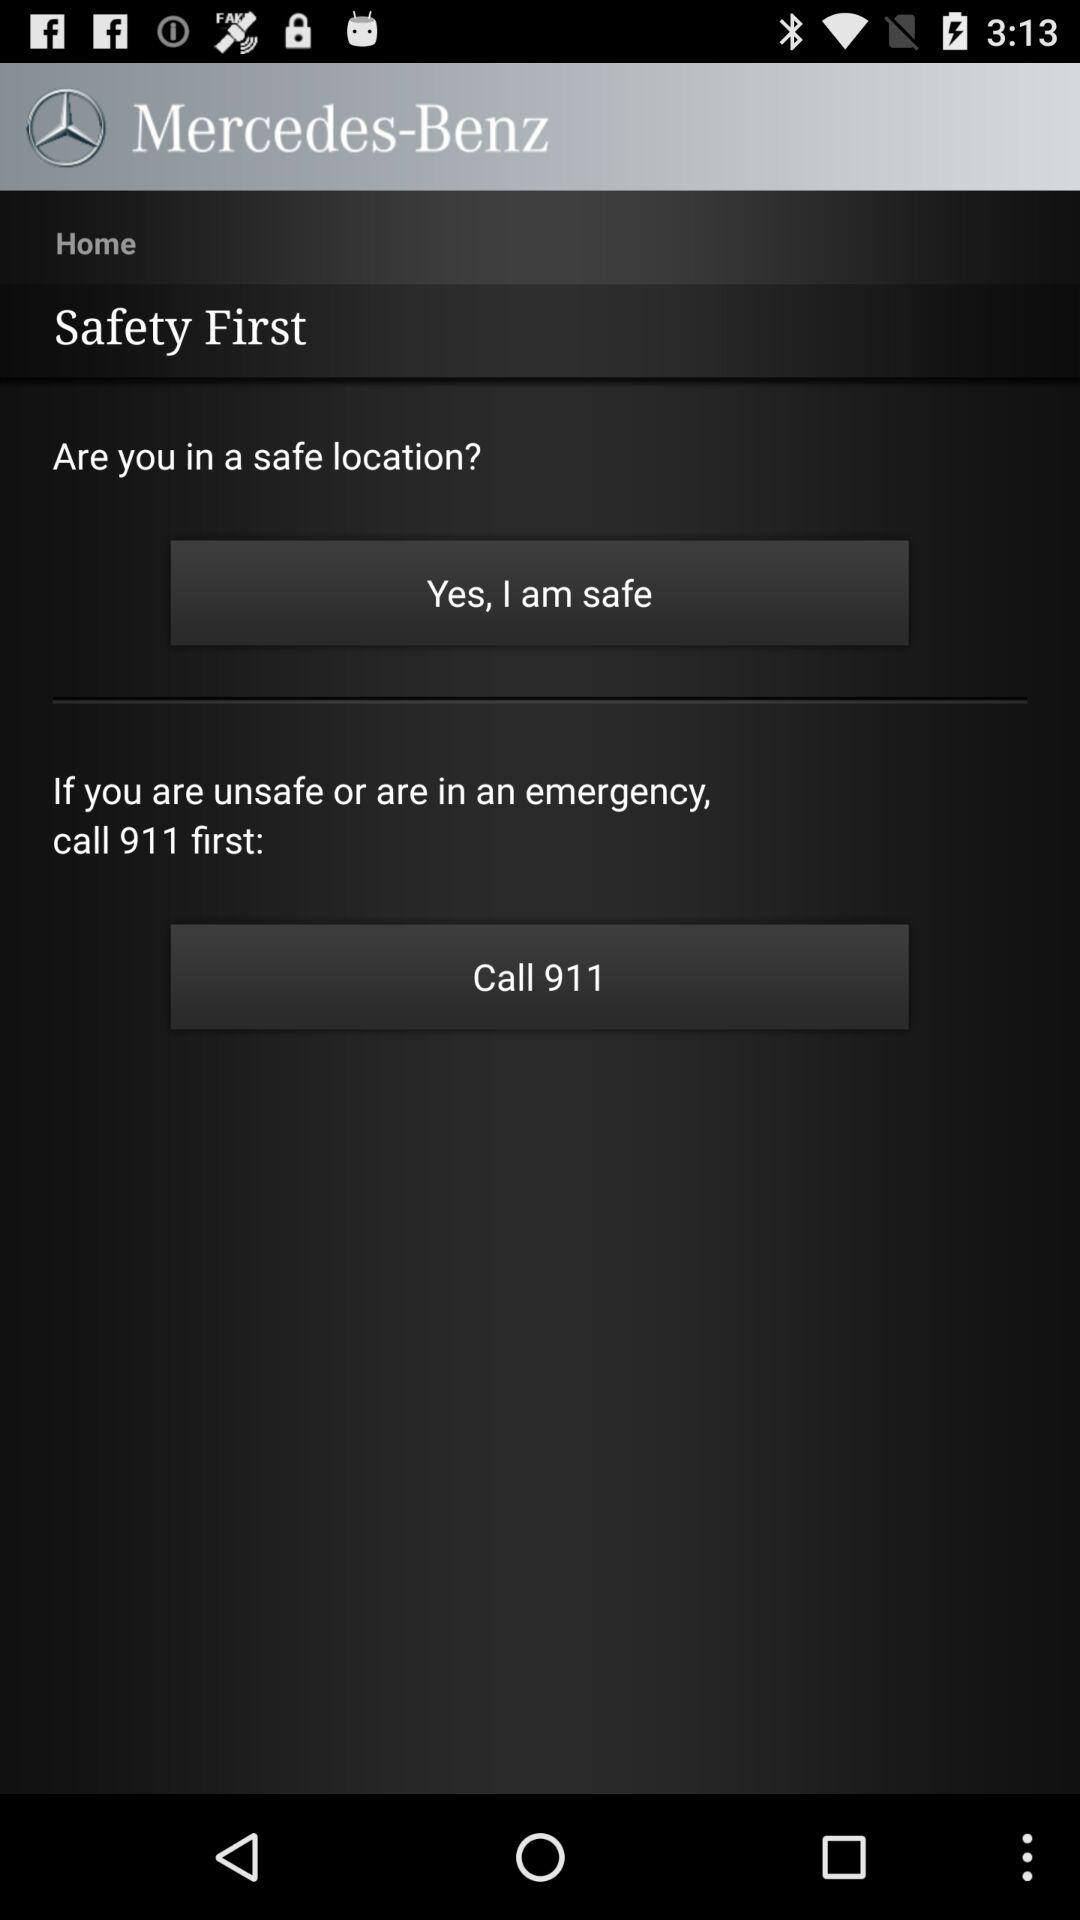Whom do I call when feeling unsafe or in an emergency? You have to call 911. 